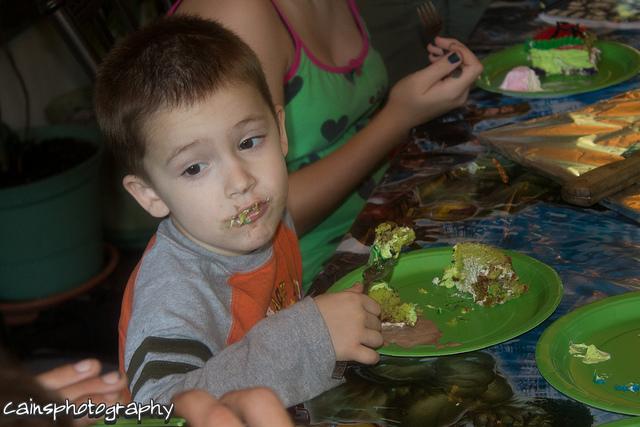What type of goods is this person surrounded by?
Keep it brief. Cake. What color is his plate?
Give a very brief answer. Green. What is the green thing?
Answer briefly. Plate. What are these people eating?
Concise answer only. Cake. What type of food is on the kid's plate?
Be succinct. Cake. What character is pictured on the tablecloth?
Give a very brief answer. Hulk. What is the celebration?
Quick response, please. Birthday. How many kids in the photo?
Write a very short answer. 1. Who are they?
Answer briefly. Kids. What are they eating?
Be succinct. Cake. What is the spoon made out of?
Write a very short answer. Metal. What utensil is being used?
Short answer required. Fork. Is the boy chewing?
Quick response, please. Yes. Are the people happy?
Be succinct. No. Is this picture taken inside the restaurant?
Short answer required. No. What is the person using to grab the food?
Concise answer only. Fork. Are the children getting junk food?
Short answer required. Yes. What is on the plate?
Quick response, please. Food. What is the gender of the child?
Keep it brief. Male. How many plates of food are on this table?
Be succinct. 3. Does the child have food on his face?
Short answer required. Yes. What kind of frosting is on the cake?
Quick response, please. Green. Is this a photograph?
Be succinct. Yes. What color is his shirt?
Quick response, please. Gray. 